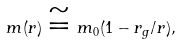<formula> <loc_0><loc_0><loc_500><loc_500>m ( r ) \cong m _ { 0 } ( 1 - r _ { g } / r ) ,</formula> 